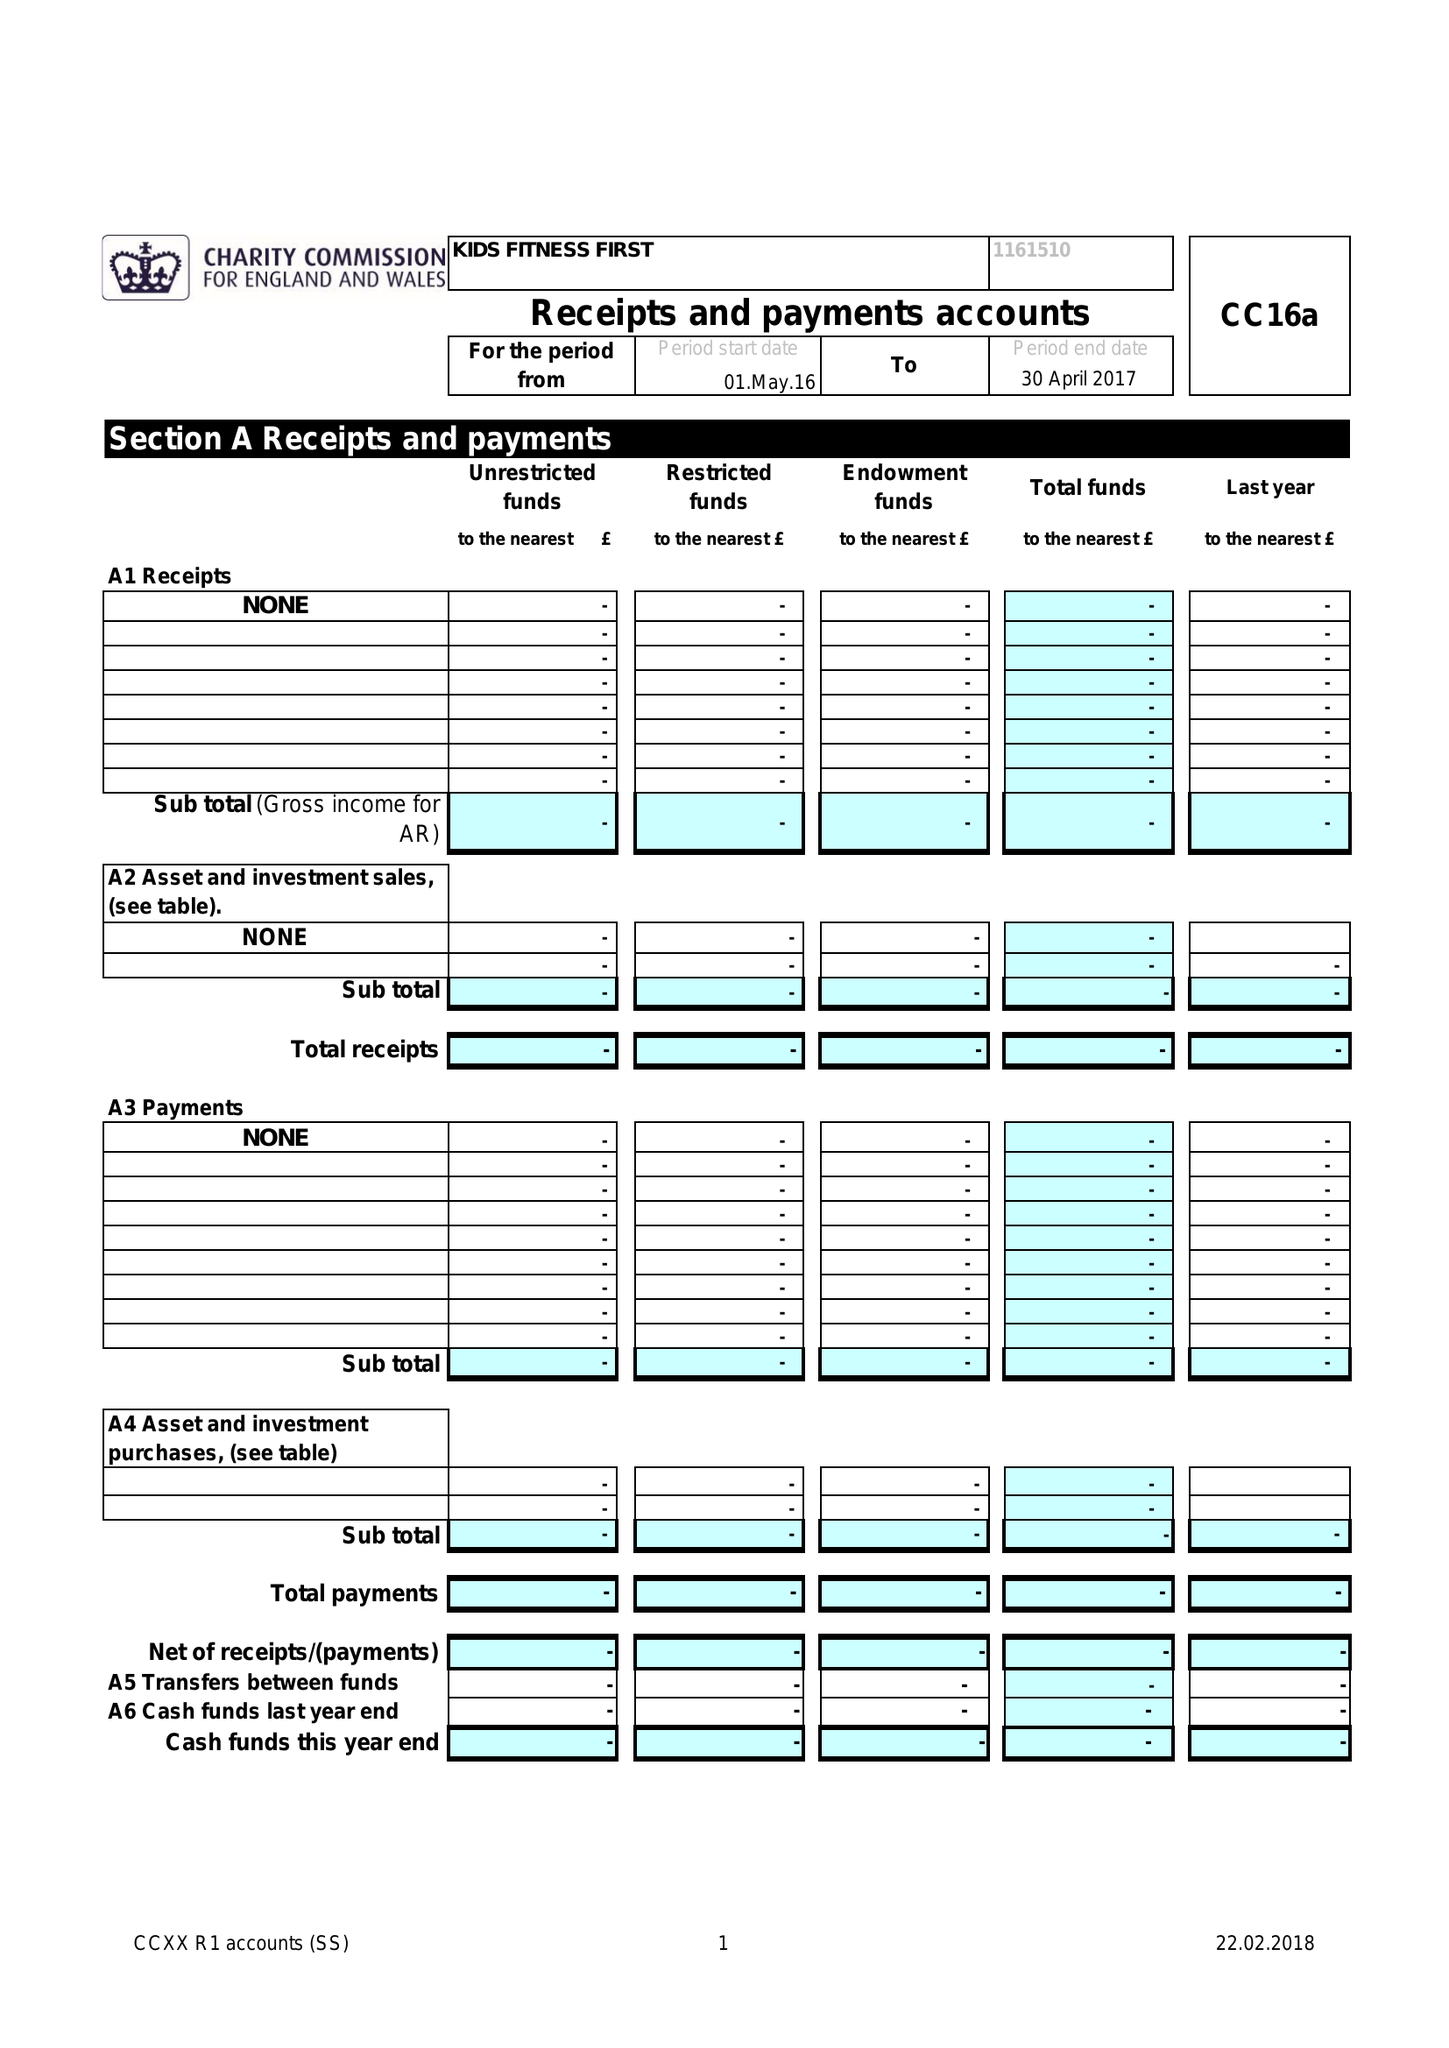What is the value for the income_annually_in_british_pounds?
Answer the question using a single word or phrase. None 